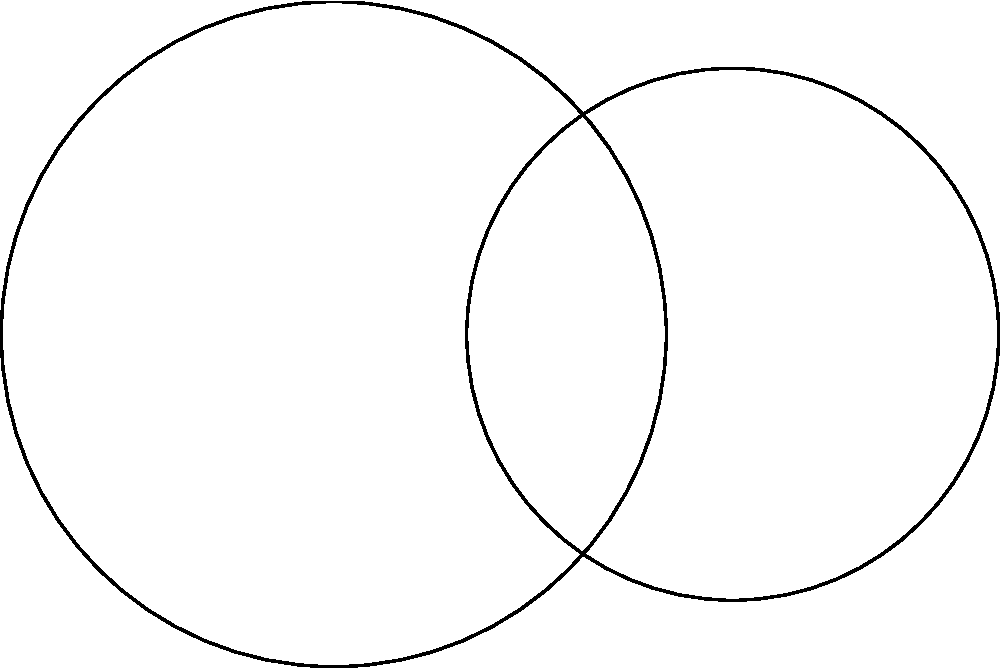As a silversmith inspired by Norse mythology, you're designing a Mjölnir-shaped pendant using the intersection of two circles. The centers of the circles are 3 cm apart, with radii 2.5 cm and 2 cm respectively. Calculate the perimeter of the Mjölnir shape formed by the intersection of these circles. To find the perimeter of the Mjölnir shape, we need to:

1) Find the points of intersection of the two circles.
2) Calculate the arc lengths of the circular segments.
3) Add the lengths of the straight lines connecting the intersection points.

Step 1: Finding intersection points
The circles intersect at two points, A and B. We don't need their exact coordinates.

Step 2: Calculating arc lengths
We need to find the central angles for each arc:

For circle 1 (radius $r_1 = 2.5$ cm):
$\cos \theta_1 = \frac{3^2 + 2.5^2 - 2^2}{2 \cdot 3 \cdot 2.5} = 0.7$
$\theta_1 = \arccos(0.7) = 0.7954$ radians

Arc length 1 = $r_1 \theta_1 = 2.5 \cdot 0.7954 = 1.9885$ cm

For circle 2 (radius $r_2 = 2$ cm):
$\cos \theta_2 = \frac{3^2 + 2^2 - 2.5^2}{2 \cdot 3 \cdot 2} = 0.2917$
$\theta_2 = \arccos(0.2917) = 1.2690$ radians

Arc length 2 = $r_2 \theta_2 = 2 \cdot 1.2690 = 2.5380$ cm

Step 3: Adding straight line segments
The straight line segments are chords of the circles. Their length can be calculated:

Chord length = $2r_1 \sin(\frac{\theta_1}{2}) = 2 \cdot 2.5 \cdot \sin(0.3977) = 1.9615$ cm

Total perimeter = Arc length 1 + Arc length 2 + 2 * Chord length
= $1.9885 + 2.5380 + 2 \cdot 1.9615 = 8.4495$ cm
Answer: $8.45$ cm 